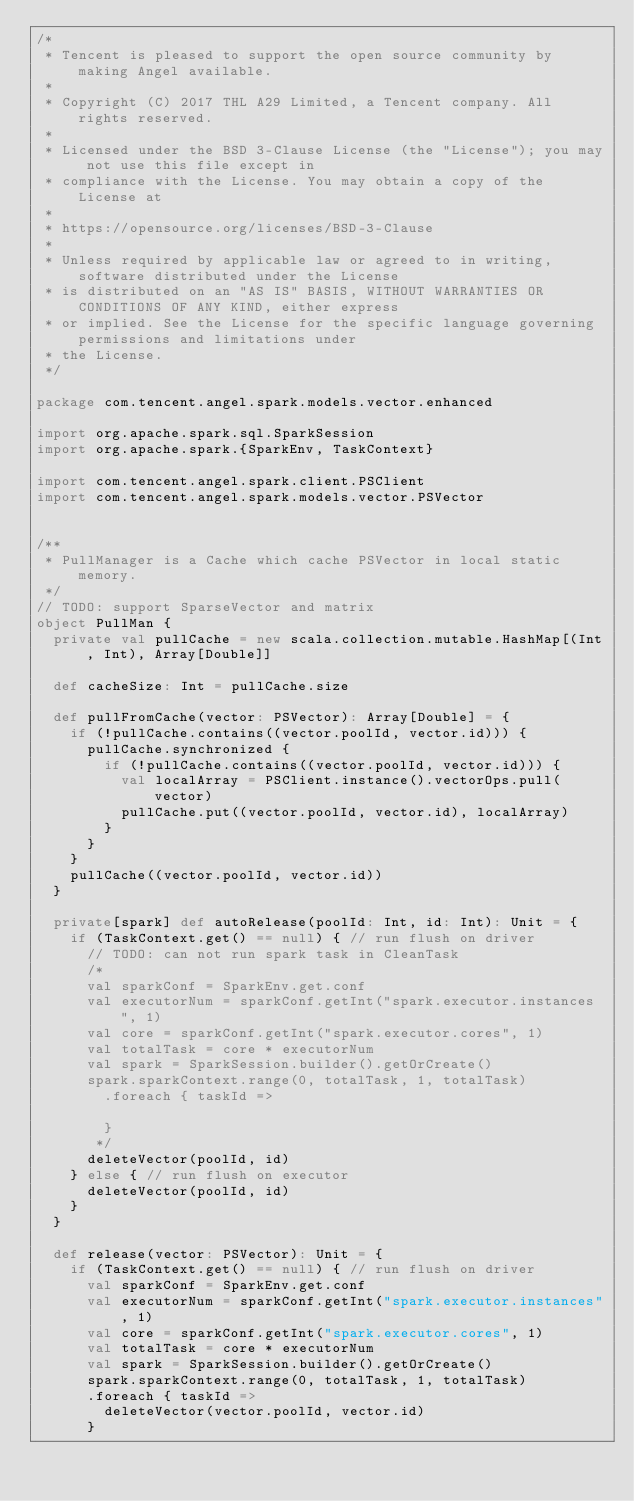Convert code to text. <code><loc_0><loc_0><loc_500><loc_500><_Scala_>/*
 * Tencent is pleased to support the open source community by making Angel available.
 *
 * Copyright (C) 2017 THL A29 Limited, a Tencent company. All rights reserved.
 *
 * Licensed under the BSD 3-Clause License (the "License"); you may not use this file except in
 * compliance with the License. You may obtain a copy of the License at
 *
 * https://opensource.org/licenses/BSD-3-Clause
 *
 * Unless required by applicable law or agreed to in writing, software distributed under the License
 * is distributed on an "AS IS" BASIS, WITHOUT WARRANTIES OR CONDITIONS OF ANY KIND, either express
 * or implied. See the License for the specific language governing permissions and limitations under
 * the License.
 */

package com.tencent.angel.spark.models.vector.enhanced

import org.apache.spark.sql.SparkSession
import org.apache.spark.{SparkEnv, TaskContext}

import com.tencent.angel.spark.client.PSClient
import com.tencent.angel.spark.models.vector.PSVector


/**
 * PullManager is a Cache which cache PSVector in local static memory.
 */
// TODO: support SparseVector and matrix
object PullMan {
  private val pullCache = new scala.collection.mutable.HashMap[(Int, Int), Array[Double]]

  def cacheSize: Int = pullCache.size

  def pullFromCache(vector: PSVector): Array[Double] = {
    if (!pullCache.contains((vector.poolId, vector.id))) {
      pullCache.synchronized {
        if (!pullCache.contains((vector.poolId, vector.id))) {
          val localArray = PSClient.instance().vectorOps.pull(vector)
          pullCache.put((vector.poolId, vector.id), localArray)
        }
      }
    }
    pullCache((vector.poolId, vector.id))
  }

  private[spark] def autoRelease(poolId: Int, id: Int): Unit = {
    if (TaskContext.get() == null) { // run flush on driver
      // TODO: can not run spark task in CleanTask
      /*
      val sparkConf = SparkEnv.get.conf
      val executorNum = sparkConf.getInt("spark.executor.instances", 1)
      val core = sparkConf.getInt("spark.executor.cores", 1)
      val totalTask = core * executorNum
      val spark = SparkSession.builder().getOrCreate()
      spark.sparkContext.range(0, totalTask, 1, totalTask)
        .foreach { taskId =>

        }
       */
      deleteVector(poolId, id)
    } else { // run flush on executor
      deleteVector(poolId, id)
    }
  }

  def release(vector: PSVector): Unit = {
    if (TaskContext.get() == null) { // run flush on driver
      val sparkConf = SparkEnv.get.conf
      val executorNum = sparkConf.getInt("spark.executor.instances", 1)
      val core = sparkConf.getInt("spark.executor.cores", 1)
      val totalTask = core * executorNum
      val spark = SparkSession.builder().getOrCreate()
      spark.sparkContext.range(0, totalTask, 1, totalTask)
      .foreach { taskId =>
        deleteVector(vector.poolId, vector.id)
      }</code> 